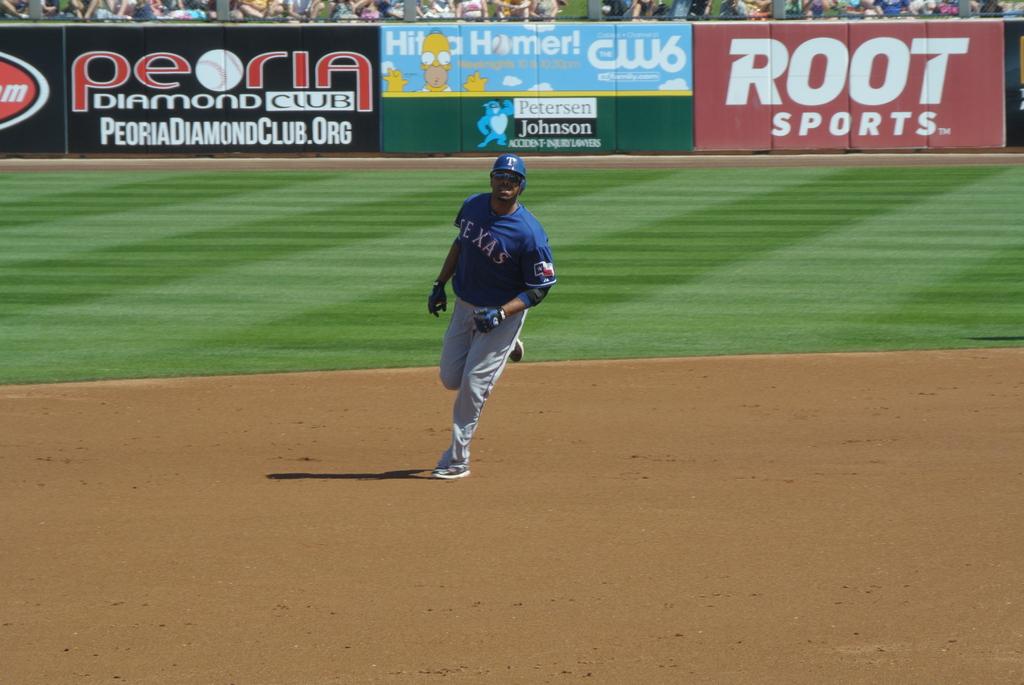What word is written above sports on the advertisement?
Make the answer very short. Root. What club is advertised?
Provide a short and direct response. Peoria diamond club. 